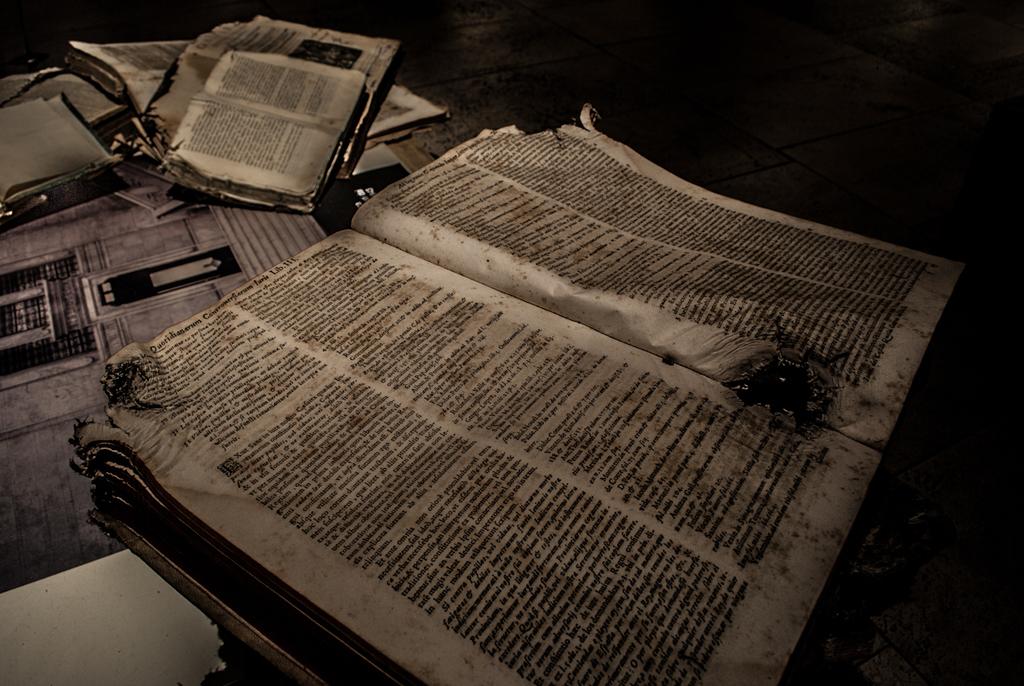Is the text written in english?
Provide a succinct answer. No. 